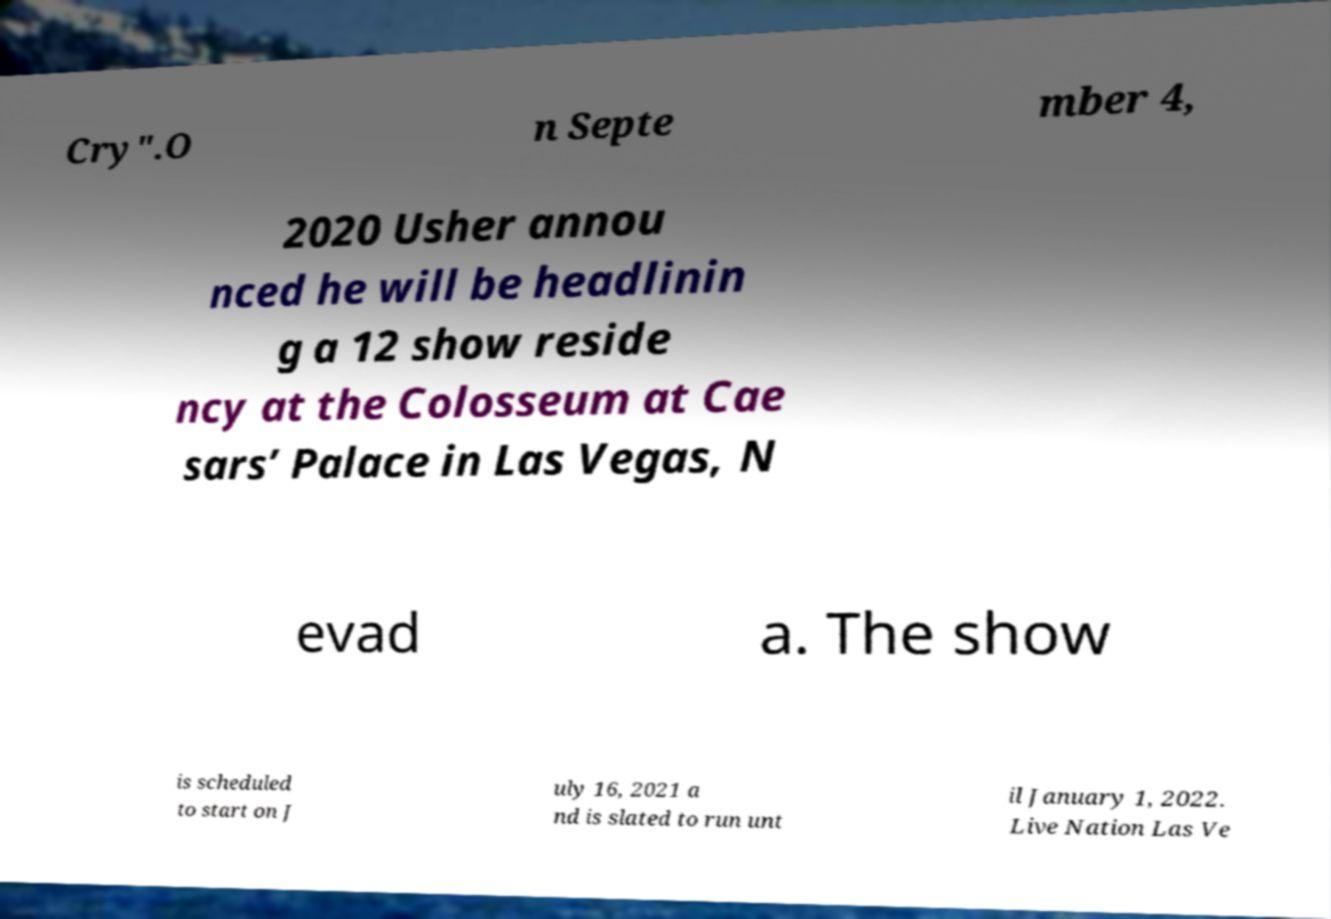Please identify and transcribe the text found in this image. Cry".O n Septe mber 4, 2020 Usher annou nced he will be headlinin g a 12 show reside ncy at the Colosseum at Cae sars’ Palace in Las Vegas, N evad a. The show is scheduled to start on J uly 16, 2021 a nd is slated to run unt il January 1, 2022. Live Nation Las Ve 